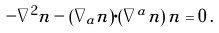<formula> <loc_0><loc_0><loc_500><loc_500>- \nabla ^ { 2 } { n } - ( \nabla _ { a } { n } ) \cdot ( \nabla ^ { a } { n } ) \, { n } = 0 \, .</formula> 